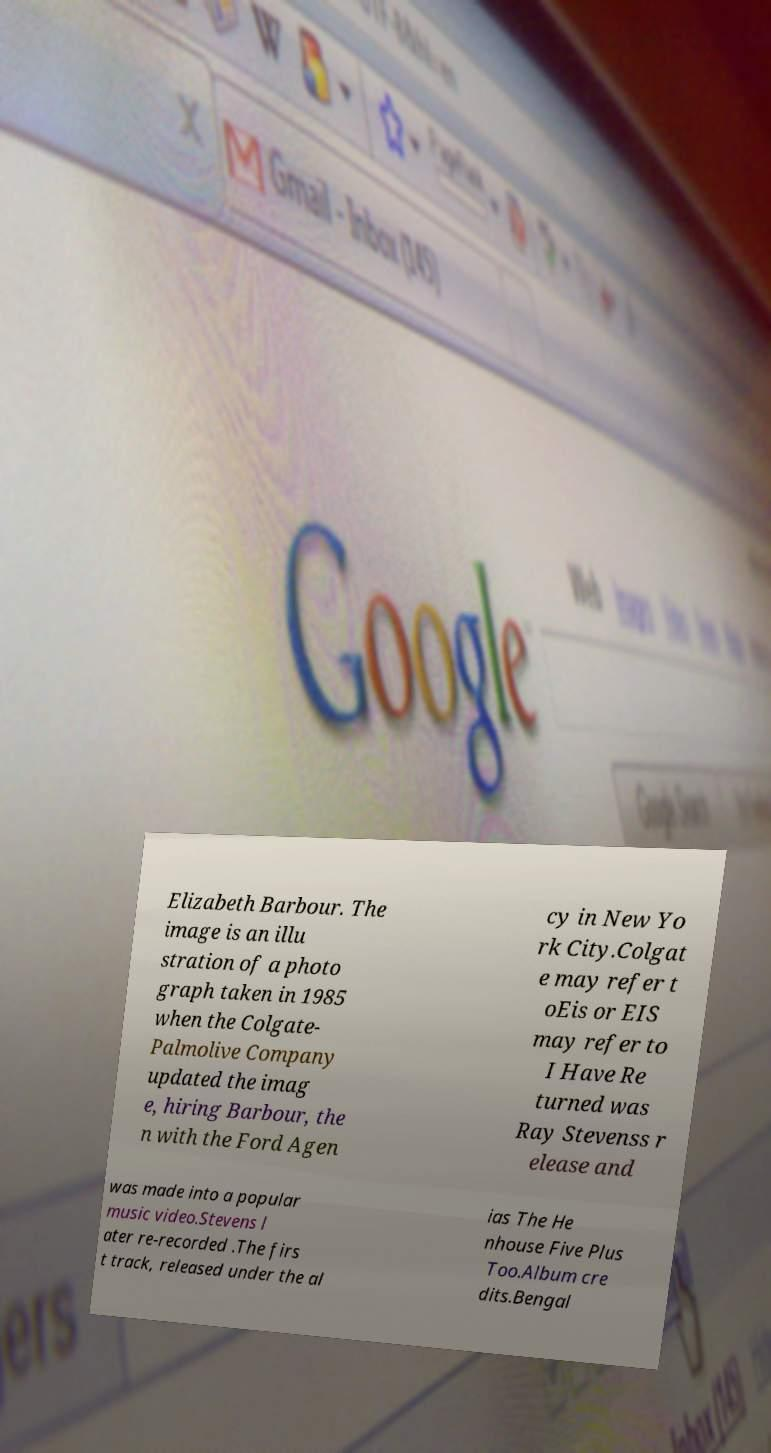There's text embedded in this image that I need extracted. Can you transcribe it verbatim? Elizabeth Barbour. The image is an illu stration of a photo graph taken in 1985 when the Colgate- Palmolive Company updated the imag e, hiring Barbour, the n with the Ford Agen cy in New Yo rk City.Colgat e may refer t oEis or EIS may refer to I Have Re turned was Ray Stevenss r elease and was made into a popular music video.Stevens l ater re-recorded .The firs t track, released under the al ias The He nhouse Five Plus Too.Album cre dits.Bengal 